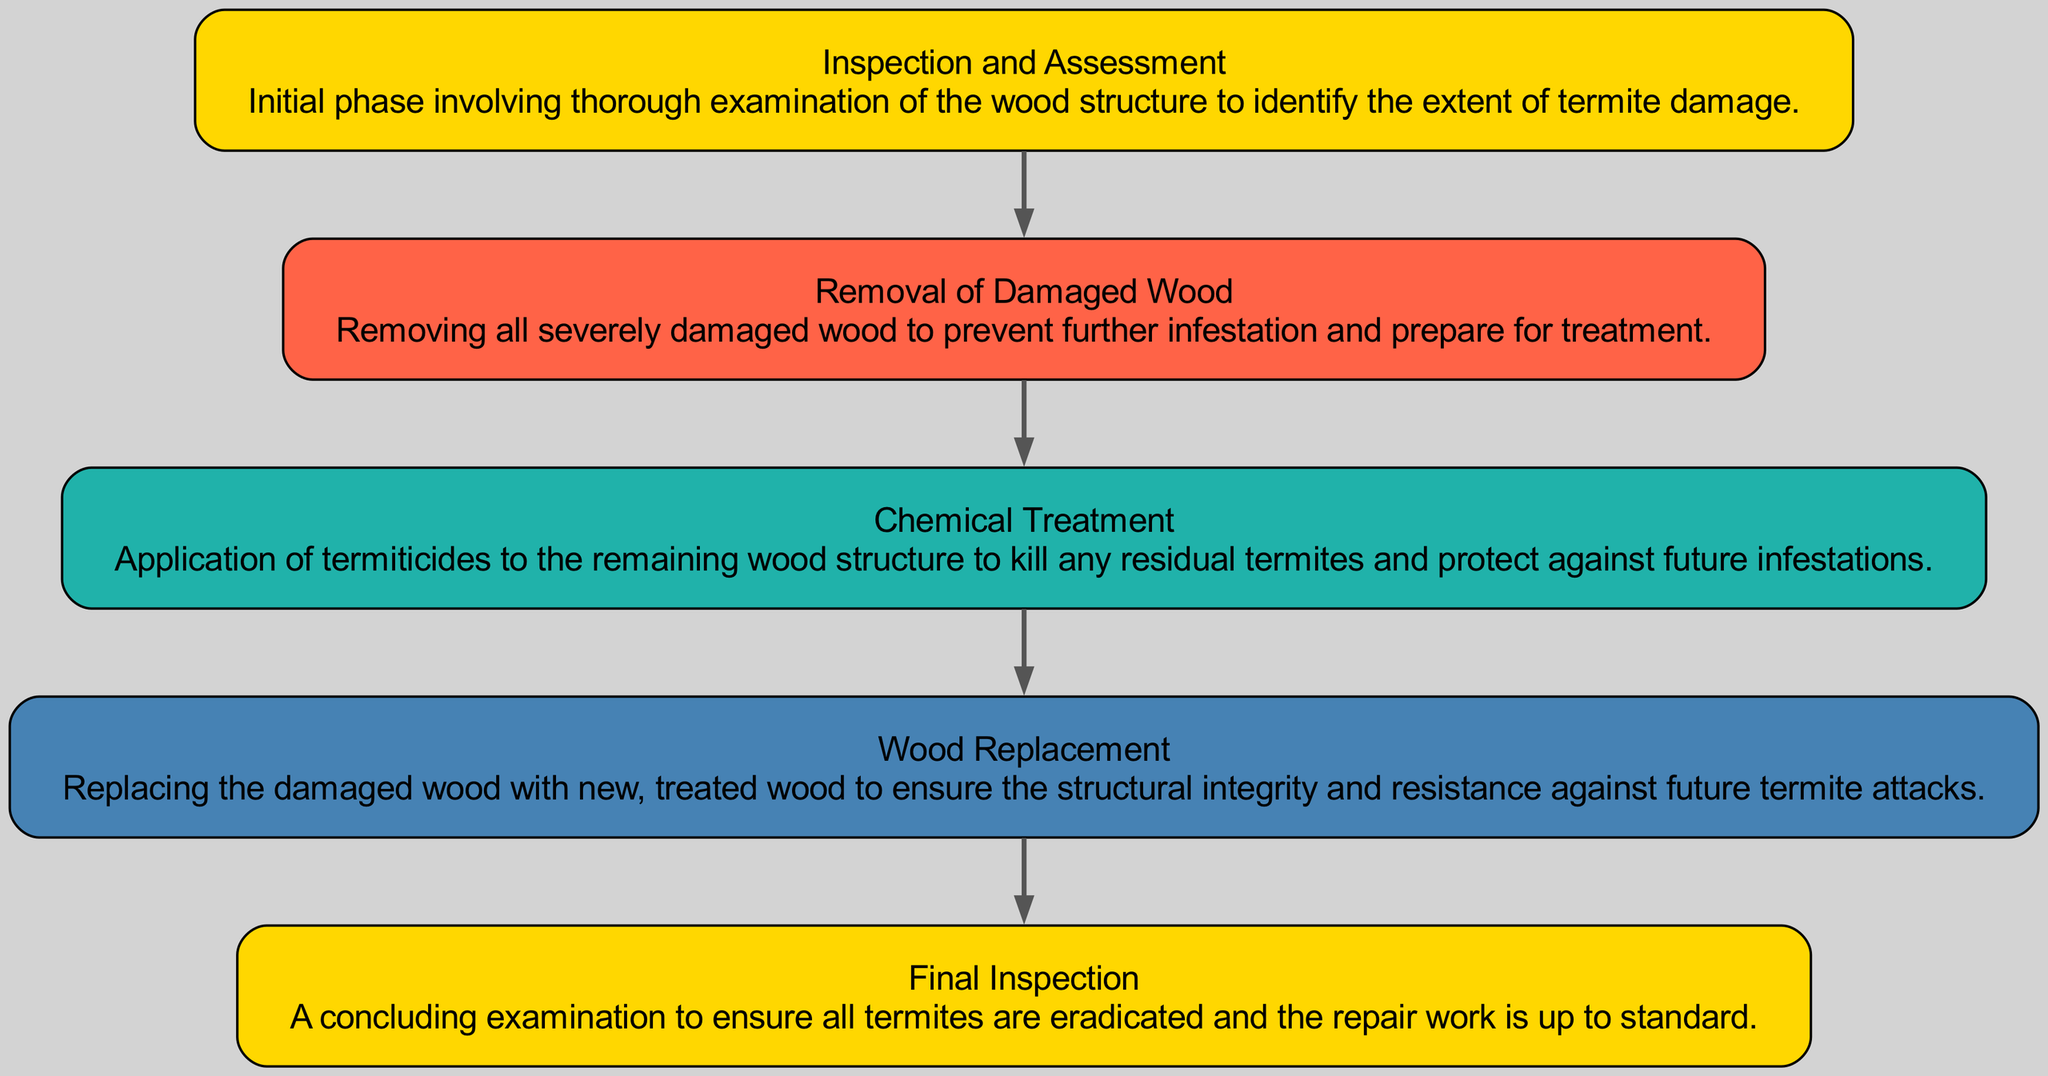What is the first step in the wood treatment process? The first step in the process is "Inspection and Assessment," as it is listed at the top of the block diagram and indicated as the initial phase of the treatment process.
Answer: Inspection and Assessment How many stages are involved in the treatment process? There are five stages involved in the treatment process, which include Inspection and Assessment, Removal of Damaged Wood, Chemical Treatment, Wood Replacement, and Final Inspection. Each stage is represented as a distinct node in the diagram.
Answer: 5 Which stage follows the "Removal of Damaged Wood"? The stage that follows "Removal of Damaged Wood" is "Chemical Treatment," as indicated by the connection arrow leading from the removal stage to the treatment stage in the diagram.
Answer: Chemical Treatment What is the purpose of the "Final Inspection" stage? The purpose of the "Final Inspection" stage is to ensure all termites are eradicated and that the repair work meets the required standards, as described in the node's information in the diagram.
Answer: Ensure eradication What color represents the "Chemical Treatment" stage? The color representing the "Chemical Treatment" stage is Light Sea Green, which is specified in the node's color designation and matches the visual representation in the diagram.
Answer: Light Sea Green What is the last step before the "Final Inspection"? The last step before the "Final Inspection" is "Wood Replacement," as it directly precedes the final examination in the order of stages shown in the diagram.
Answer: Wood Replacement What do all stages have in common? All stages share the common goal of addressing termite infestation and structural integrity, as they are connected sequentially to achieve complete treatment and repair in the diagram.
Answer: Addressing termite infestation How many connections are there from "Inspection and Assessment"? There is one connection from "Inspection and Assessment," which leads to the "Removal of Damaged Wood" stage, as depicted by the directed arrow in the diagram.
Answer: 1 Which stage includes the application of termiticides? "Chemical Treatment" is the stage that includes the application of termiticides, as explicitly stated in the description of that node in the diagram.
Answer: Chemical Treatment 